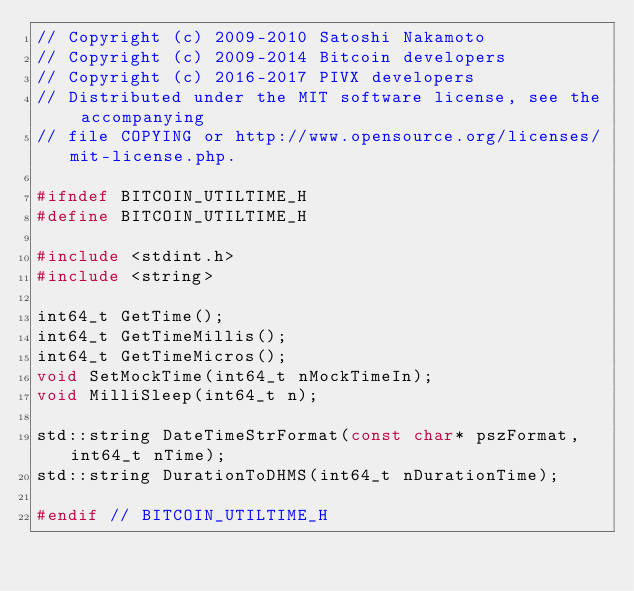<code> <loc_0><loc_0><loc_500><loc_500><_C_>// Copyright (c) 2009-2010 Satoshi Nakamoto
// Copyright (c) 2009-2014 Bitcoin developers
// Copyright (c) 2016-2017 PIVX developers
// Distributed under the MIT software license, see the accompanying
// file COPYING or http://www.opensource.org/licenses/mit-license.php.

#ifndef BITCOIN_UTILTIME_H
#define BITCOIN_UTILTIME_H

#include <stdint.h>
#include <string>

int64_t GetTime();
int64_t GetTimeMillis();
int64_t GetTimeMicros();
void SetMockTime(int64_t nMockTimeIn);
void MilliSleep(int64_t n);

std::string DateTimeStrFormat(const char* pszFormat, int64_t nTime);
std::string DurationToDHMS(int64_t nDurationTime);

#endif // BITCOIN_UTILTIME_H
</code> 